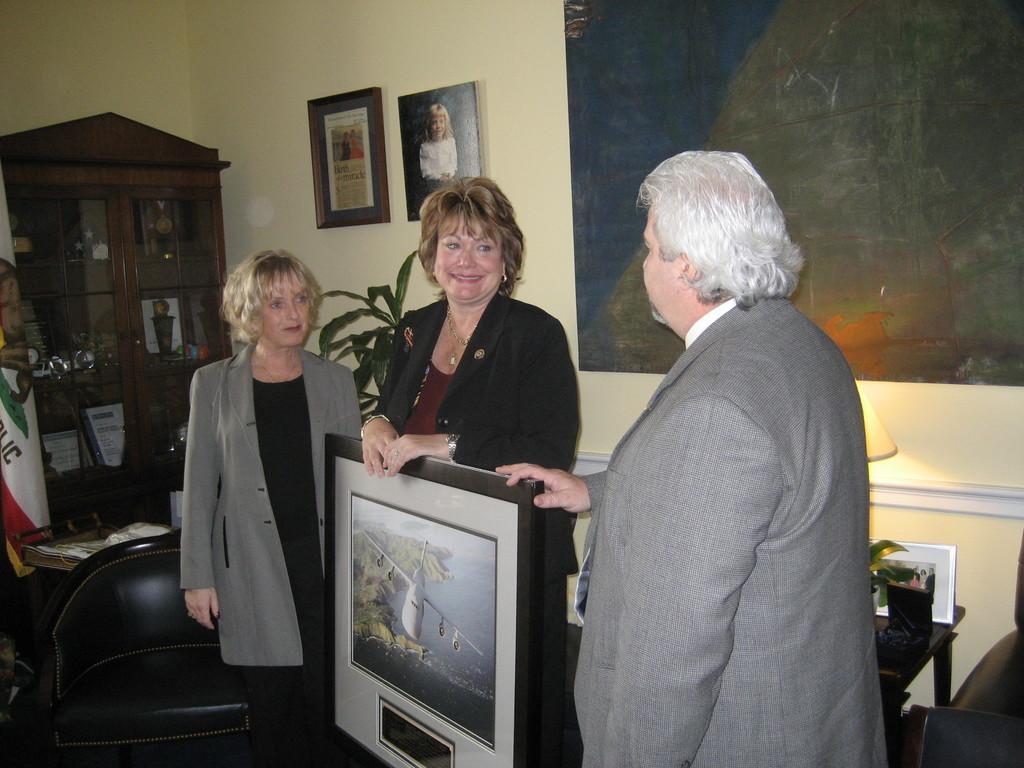In one or two sentences, can you explain what this image depicts? In this image we can see some people standing. One man and a woman are holding a frame in their hands. On the right side of the image we can see a lamp, photo frame placed on the table. On the left side of the image we can see some objects placed in cupboards, a plant, flag and a chair placed on the ground. In the background, we can see some photo frames on the wall. 